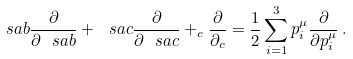Convert formula to latex. <formula><loc_0><loc_0><loc_500><loc_500>\ s a b \frac { \partial } { \partial \ s a b } + \ s a c \frac { \partial } { \partial \ s a c } + _ { c } \frac { \partial } { \partial _ { c } } = \frac { 1 } { 2 } \sum _ { i = 1 } ^ { 3 } p _ { i } ^ { \mu } \frac { \partial } { \partial p _ { i } ^ { \mu } } \, .</formula> 